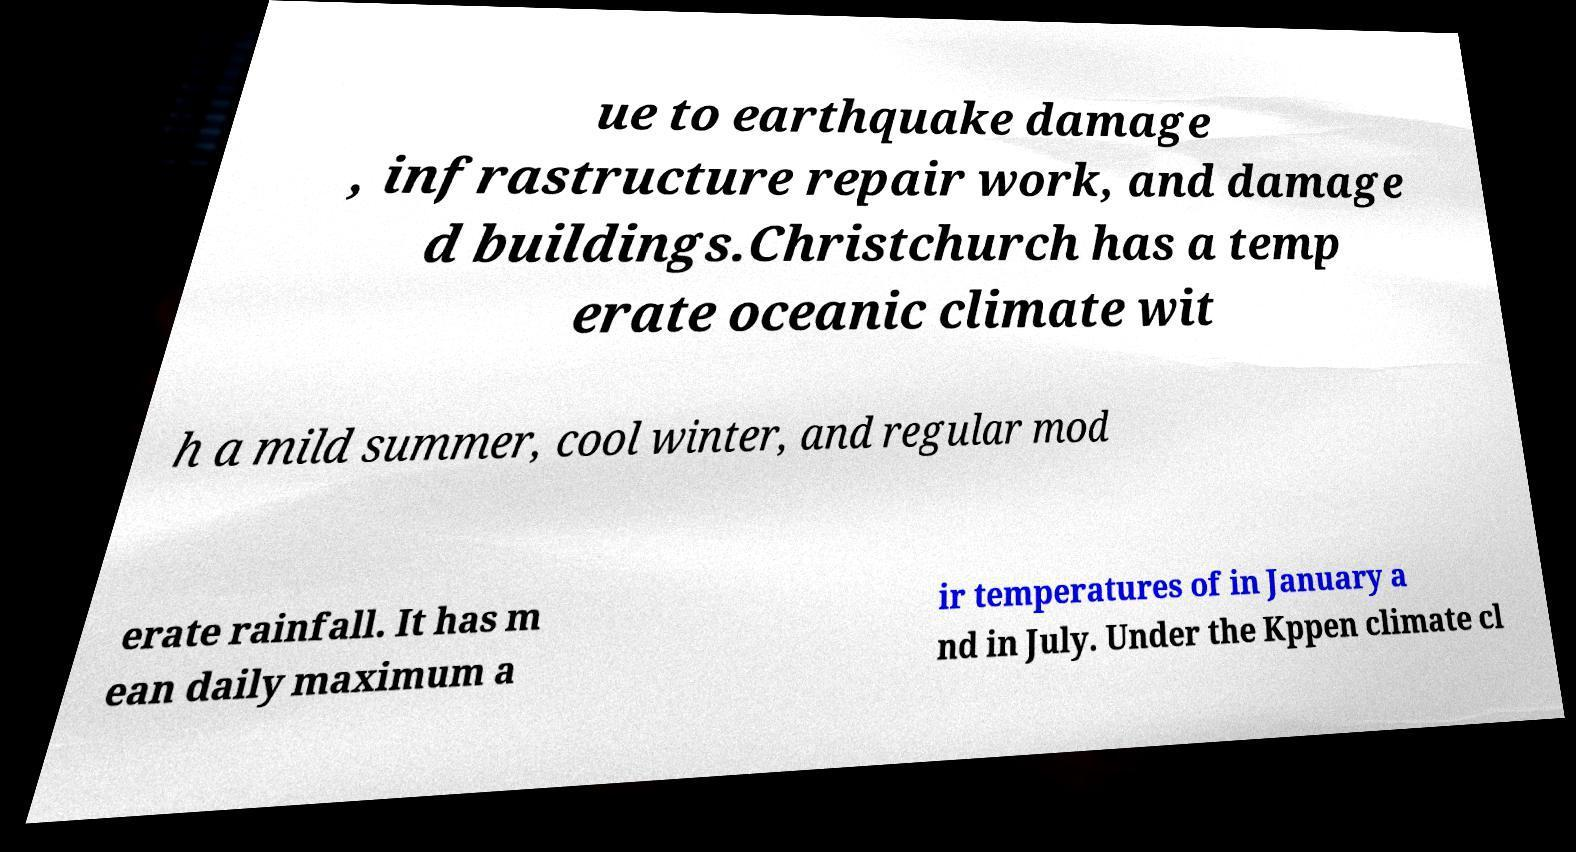Please read and relay the text visible in this image. What does it say? ue to earthquake damage , infrastructure repair work, and damage d buildings.Christchurch has a temp erate oceanic climate wit h a mild summer, cool winter, and regular mod erate rainfall. It has m ean daily maximum a ir temperatures of in January a nd in July. Under the Kppen climate cl 